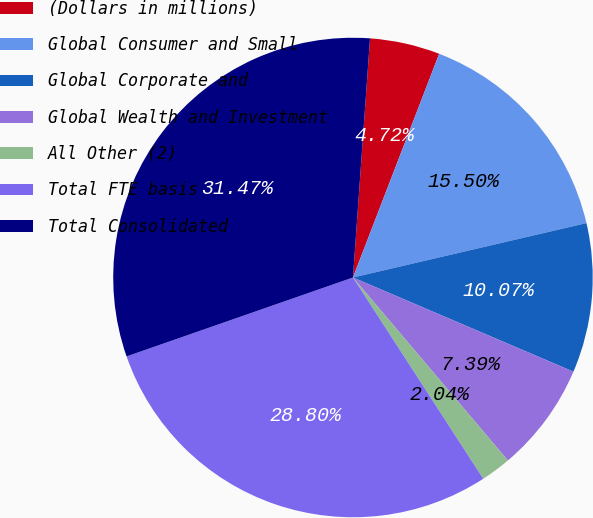Convert chart to OTSL. <chart><loc_0><loc_0><loc_500><loc_500><pie_chart><fcel>(Dollars in millions)<fcel>Global Consumer and Small<fcel>Global Corporate and<fcel>Global Wealth and Investment<fcel>All Other (2)<fcel>Total FTE basis<fcel>Total Consolidated<nl><fcel>4.72%<fcel>15.5%<fcel>10.07%<fcel>7.39%<fcel>2.04%<fcel>28.8%<fcel>31.47%<nl></chart> 